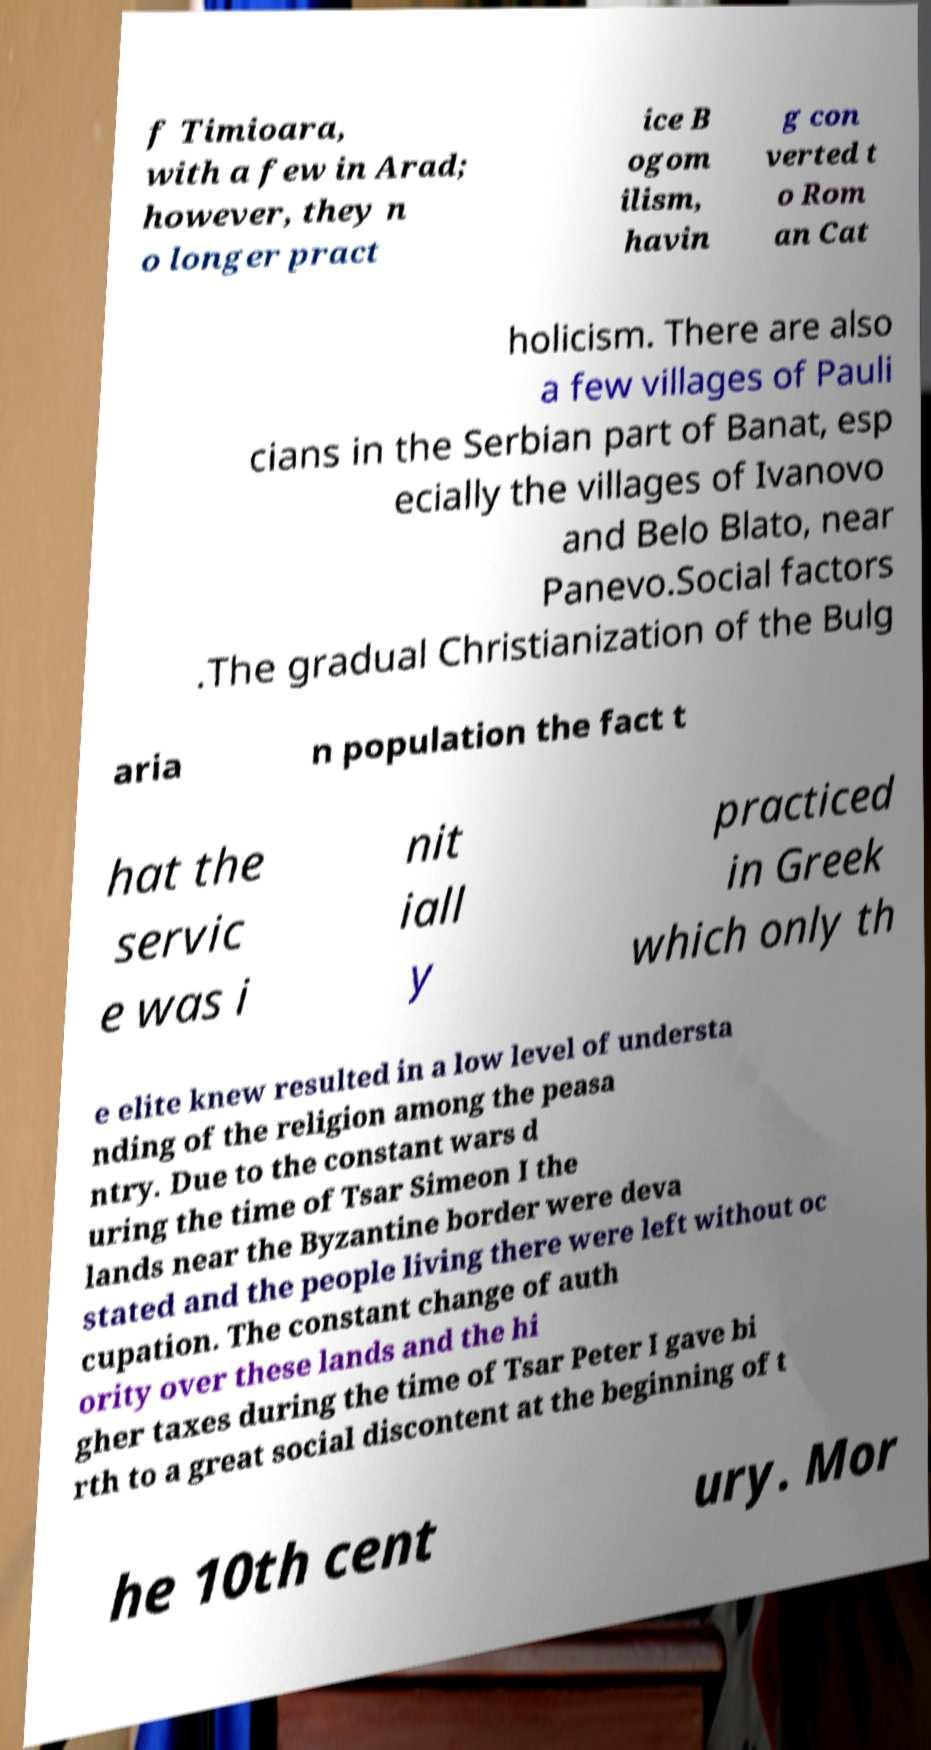Can you read and provide the text displayed in the image?This photo seems to have some interesting text. Can you extract and type it out for me? f Timioara, with a few in Arad; however, they n o longer pract ice B ogom ilism, havin g con verted t o Rom an Cat holicism. There are also a few villages of Pauli cians in the Serbian part of Banat, esp ecially the villages of Ivanovo and Belo Blato, near Panevo.Social factors .The gradual Christianization of the Bulg aria n population the fact t hat the servic e was i nit iall y practiced in Greek which only th e elite knew resulted in a low level of understa nding of the religion among the peasa ntry. Due to the constant wars d uring the time of Tsar Simeon I the lands near the Byzantine border were deva stated and the people living there were left without oc cupation. The constant change of auth ority over these lands and the hi gher taxes during the time of Tsar Peter I gave bi rth to a great social discontent at the beginning of t he 10th cent ury. Mor 